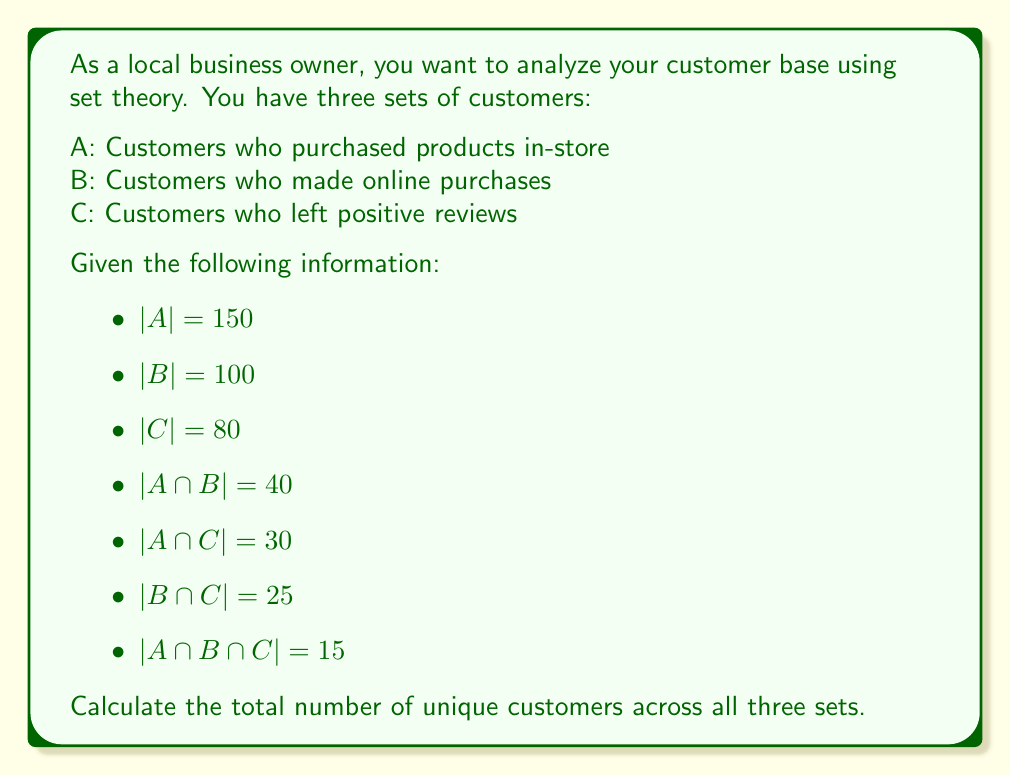Can you answer this question? To solve this problem, we'll use the inclusion-exclusion principle for three sets:

$|A \cup B \cup C| = |A| + |B| + |C| - |A \cap B| - |A \cap C| - |B \cap C| + |A \cap B \cap C|$

Let's substitute the given values:

$|A \cup B \cup C| = 150 + 100 + 80 - 40 - 30 - 25 + 15$

Now, let's calculate step by step:

1. Add the individual set sizes:
   $150 + 100 + 80 = 330$

2. Subtract the pairwise intersections:
   $330 - 40 - 30 - 25 = 235$

3. Add back the triple intersection:
   $235 + 15 = 250$

Therefore, the total number of unique customers across all three sets is 250.
Answer: 250 unique customers 